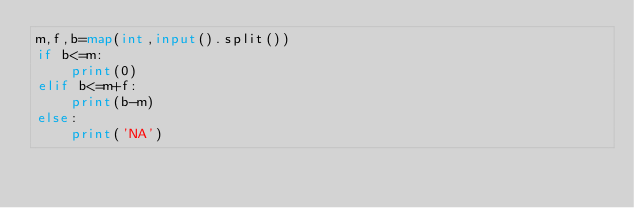<code> <loc_0><loc_0><loc_500><loc_500><_Python_>m,f,b=map(int,input().split())
if b<=m:
    print(0)
elif b<=m+f:
    print(b-m)
else:
    print('NA')
</code> 